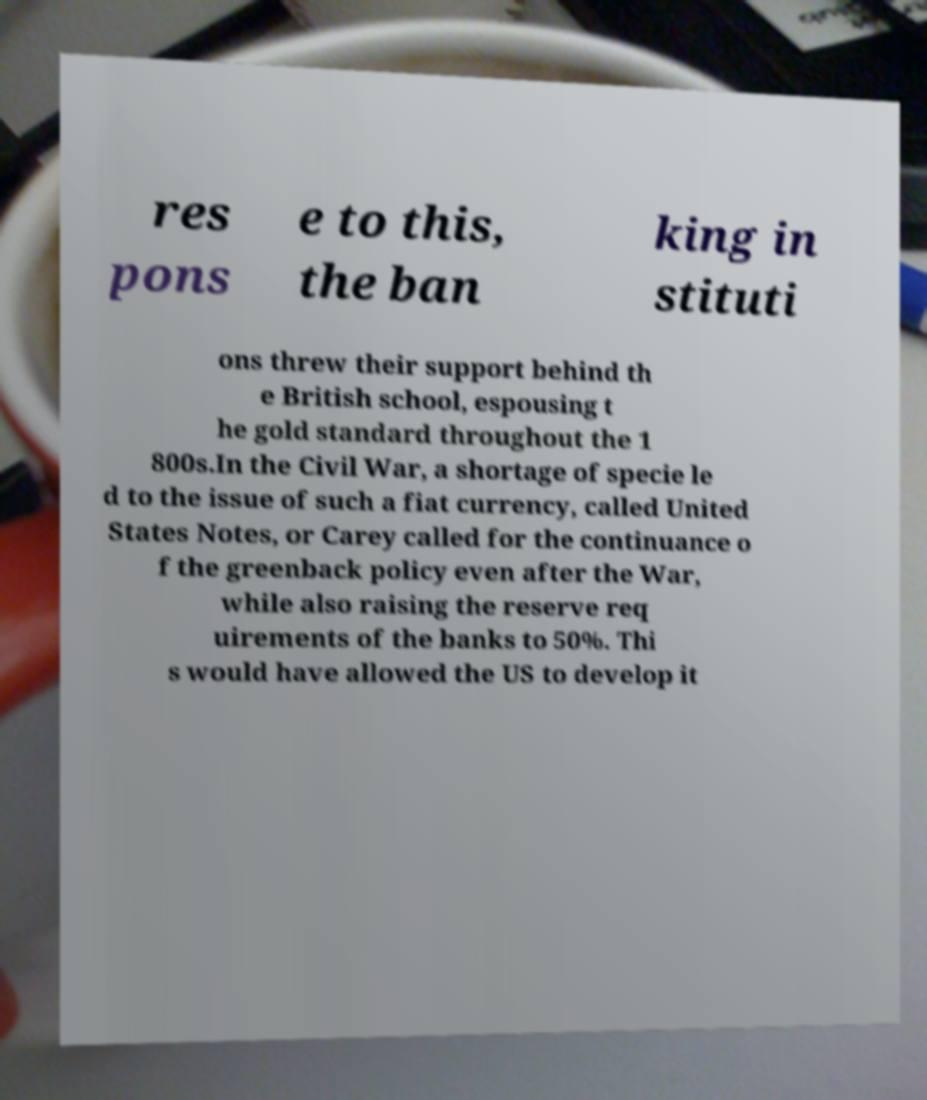I need the written content from this picture converted into text. Can you do that? res pons e to this, the ban king in stituti ons threw their support behind th e British school, espousing t he gold standard throughout the 1 800s.In the Civil War, a shortage of specie le d to the issue of such a fiat currency, called United States Notes, or Carey called for the continuance o f the greenback policy even after the War, while also raising the reserve req uirements of the banks to 50%. Thi s would have allowed the US to develop it 